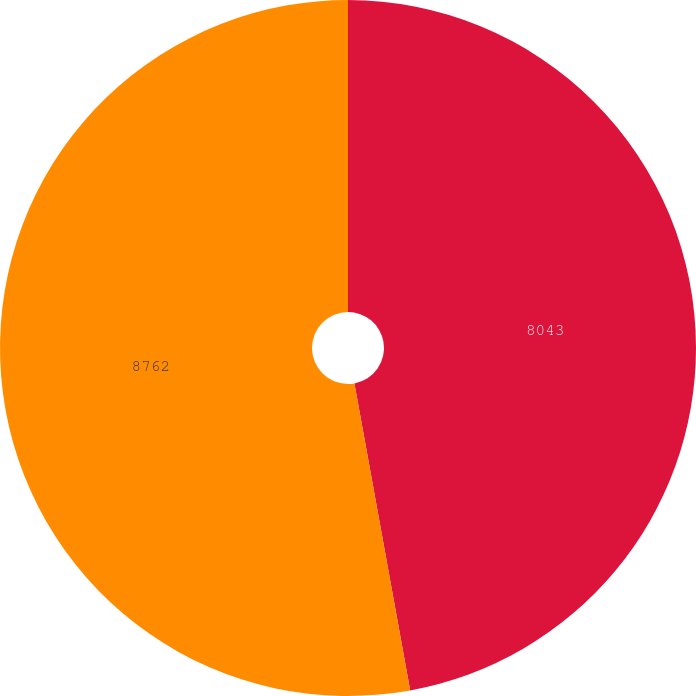Convert chart. <chart><loc_0><loc_0><loc_500><loc_500><pie_chart><fcel>8043<fcel>8762<nl><fcel>47.14%<fcel>52.86%<nl></chart> 